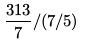<formula> <loc_0><loc_0><loc_500><loc_500>\frac { 3 1 3 } { 7 } / ( 7 / 5 )</formula> 